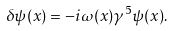Convert formula to latex. <formula><loc_0><loc_0><loc_500><loc_500>\delta \psi ( x ) = - i \omega ( x ) \gamma ^ { 5 } \psi ( x ) .</formula> 